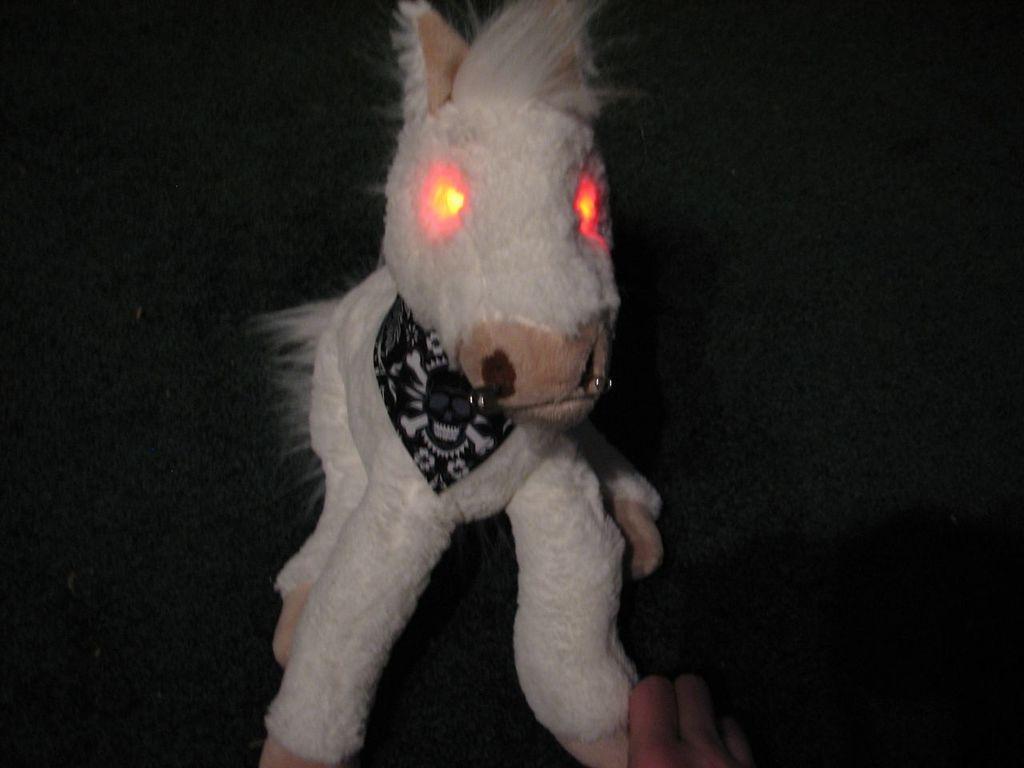Could you give a brief overview of what you see in this image? In this image there is a toy, in the background it is dark. 